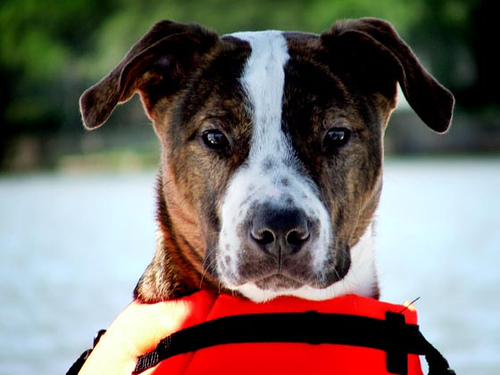<image>
Is there a dog above the floor? No. The dog is not positioned above the floor. The vertical arrangement shows a different relationship. 